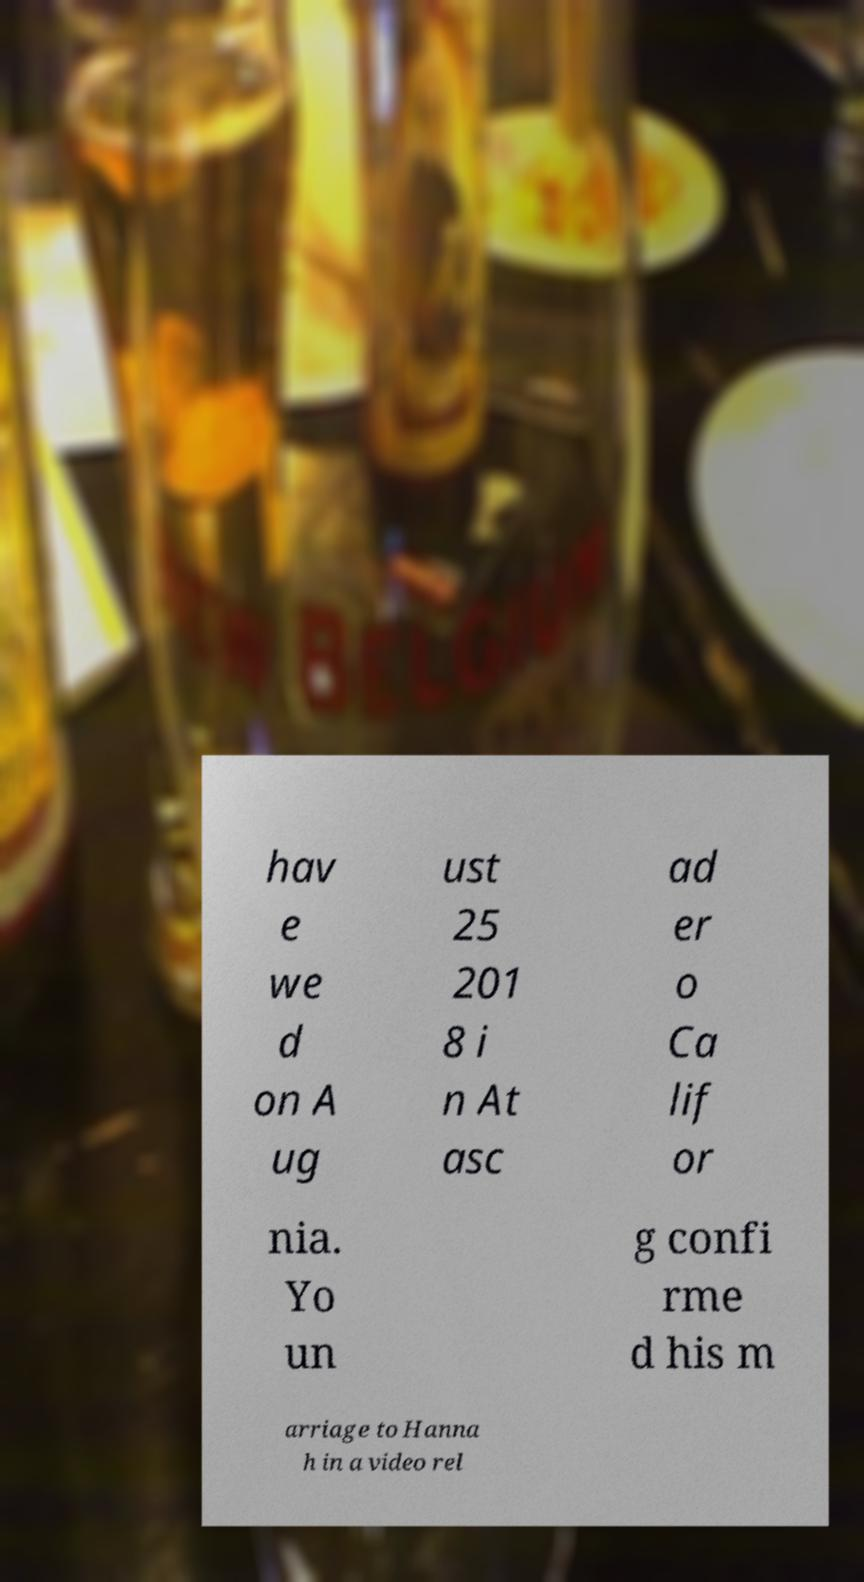Could you extract and type out the text from this image? hav e we d on A ug ust 25 201 8 i n At asc ad er o Ca lif or nia. Yo un g confi rme d his m arriage to Hanna h in a video rel 